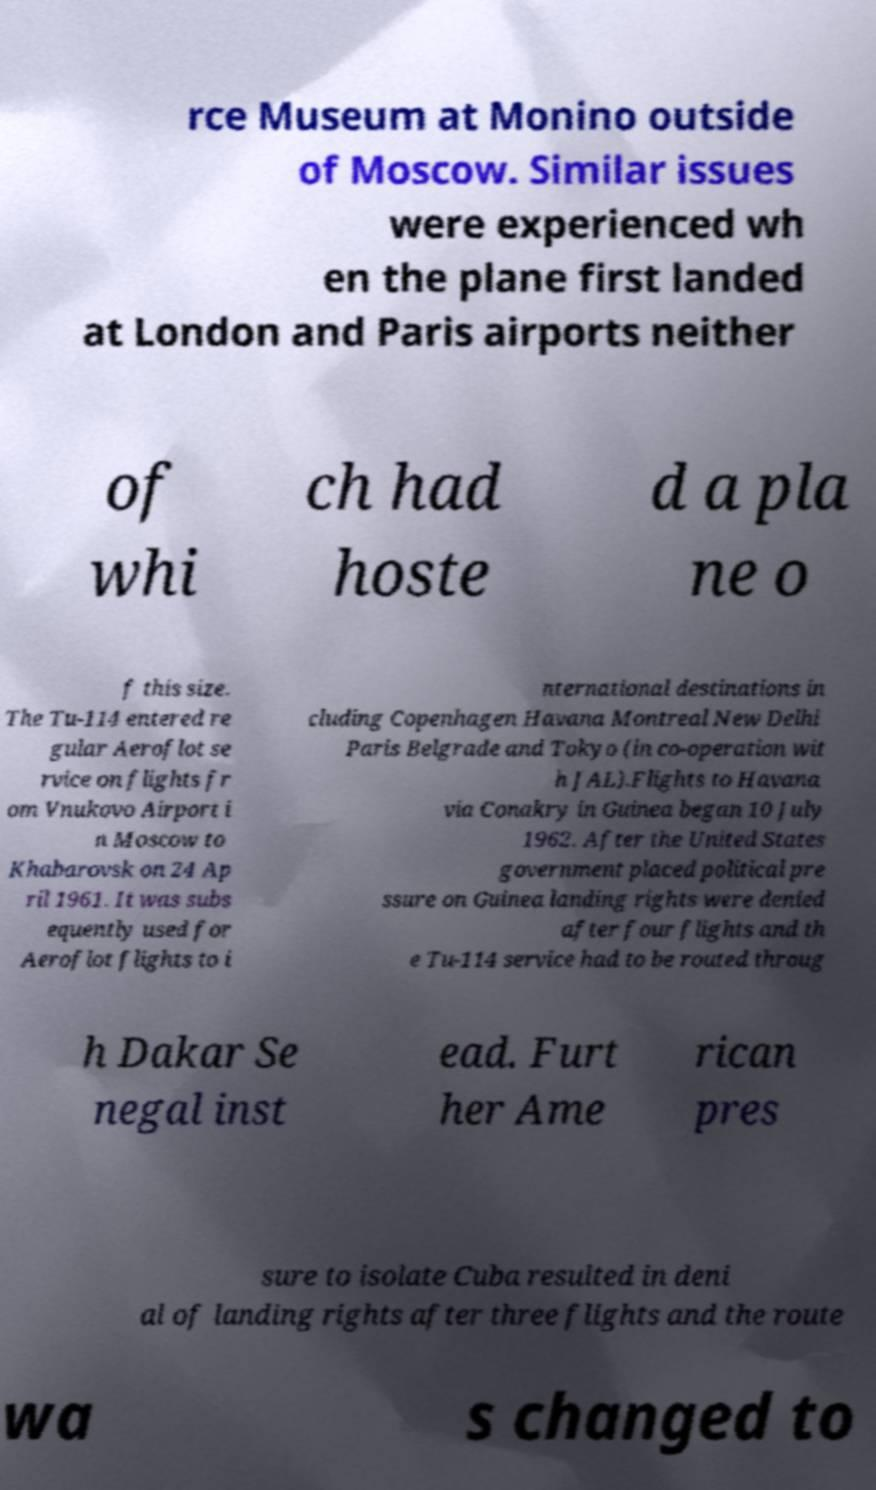Could you assist in decoding the text presented in this image and type it out clearly? rce Museum at Monino outside of Moscow. Similar issues were experienced wh en the plane first landed at London and Paris airports neither of whi ch had hoste d a pla ne o f this size. The Tu-114 entered re gular Aeroflot se rvice on flights fr om Vnukovo Airport i n Moscow to Khabarovsk on 24 Ap ril 1961. It was subs equently used for Aeroflot flights to i nternational destinations in cluding Copenhagen Havana Montreal New Delhi Paris Belgrade and Tokyo (in co-operation wit h JAL).Flights to Havana via Conakry in Guinea began 10 July 1962. After the United States government placed political pre ssure on Guinea landing rights were denied after four flights and th e Tu-114 service had to be routed throug h Dakar Se negal inst ead. Furt her Ame rican pres sure to isolate Cuba resulted in deni al of landing rights after three flights and the route wa s changed to 